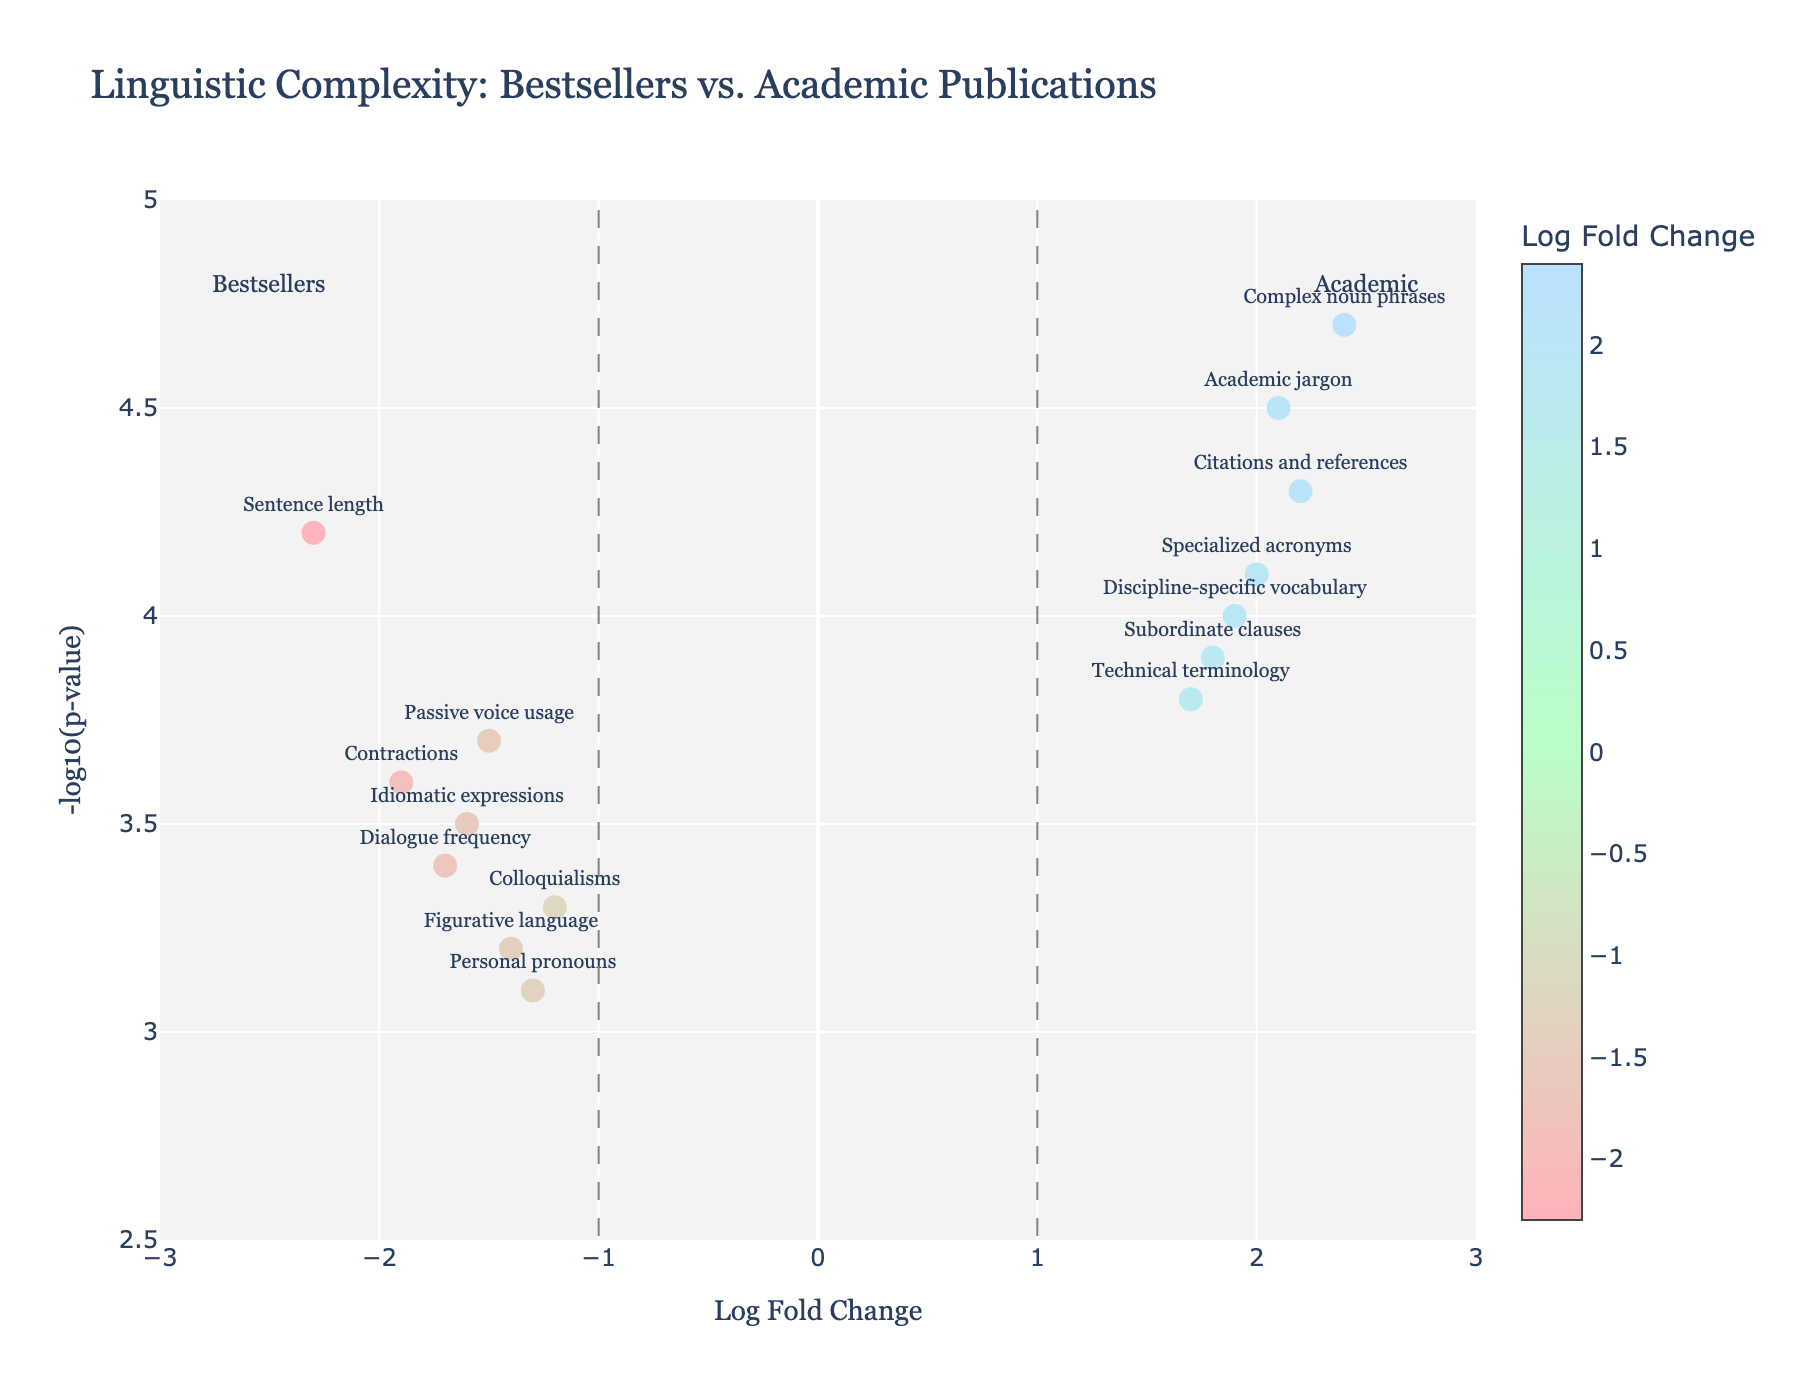What does the x-axis represent in this plot? The x-axis represents the Log Fold Change, indicating the ratio of linguistic feature usage between bestselling books and academic publications. The axis is labeled "Log Fold Change."
Answer: Log Fold Change What feature has the highest negative Log Fold Change? The highest negative Log Fold Change is observed for the feature "Sentence length" which is positioned at -2.3 on the x-axis.
Answer: Sentence length Which data point has the highest -log10(p-value)? "Complex noun phrases" has the highest -log10(p-value), positioned at 4.7 on the y-axis.
Answer: Complex noun phrases Are there any features that have both a Log Fold Change greater than 2 and a -log10(p-value) above 4? Checking the plot, "Complex noun phrases" has a Log Fold Change of 2.4 and a -log10(p-value) of 4.7.
Answer: Yes, Complex noun phrases How many features have a Log Fold Change greater than 1? The features with Log Fold Changes greater than 1 are "Subordinate clauses," "Academic jargon," "Technical terminology," "Complex noun phrases," "Specialized acronyms," "Discipline-specific vocabulary," and "Citations and references." Counting these features gives a total of 7.
Answer: 7 Which feature shows the highest statistical significance favoring academic publications? The most statistically significant feature favoring academic publications (with the highest -log10(p-value)) is "Complex noun phrases" with a -log10(p-value) of 4.7.
Answer: Complex noun phrases Is the usage of personal pronouns more prevalent in bestselling books or academic publications? The Log Fold Change for "Personal pronouns" is -1.3, indicating they are more prevalent in bestselling books.
Answer: Bestselling books Which linguistic features show a statistically significant difference favoring academic publications? Features located on the right side of the vertical line at Log Fold Change of 1 and above the horizontal line at -log10(p-value) of 2 indicate statistical significance favoring academic publications. These features include "Subordinate clauses," "Academic jargon," "Technical terminology," "Complex noun phrases," "Specialized acronyms," "Discipline-specific vocabulary," and "Citations and references."
Answer: Subordinate clauses, Academic jargon, Technical terminology, Complex noun phrases, Specialized acronyms, Discipline-specific vocabulary, Citations and references Which feature has the lowest Log Fold Change but is statistically significant? "Sentence length" has the lowest Log Fold Change at -2.3 and is also statistically significant as it is above the -log10(p-value) threshold.
Answer: Sentence length Among "Dialogue frequency" and "Technical terminology," which is more prevalent in academic publications? "Technical terminology" has a Log Fold Change of 1.7, indicating it is more prevalent in academic publications, while "Dialogue frequency" has a Log Fold Change of -1.7, indicating it is more prevalent in bestselling books.
Answer: Technical terminology 